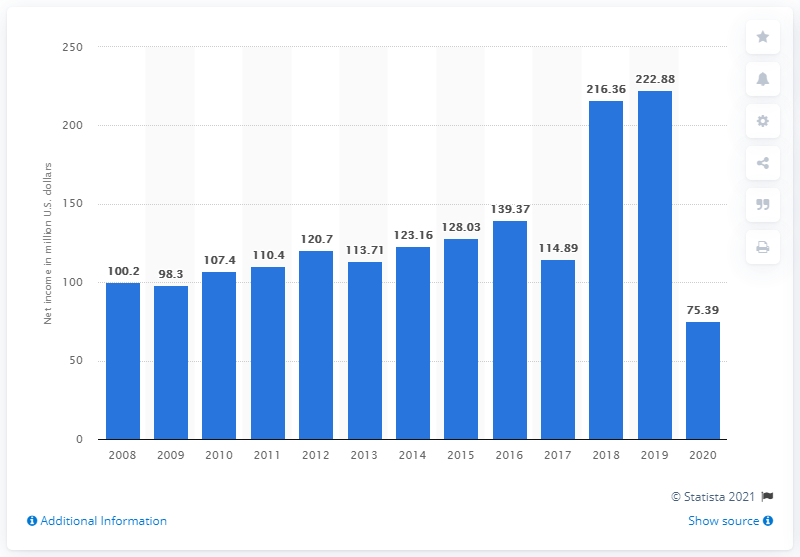Give some essential details in this illustration. The net income of Choice Hotels International Inc. during the 2020 financial year was $75.39 million. 